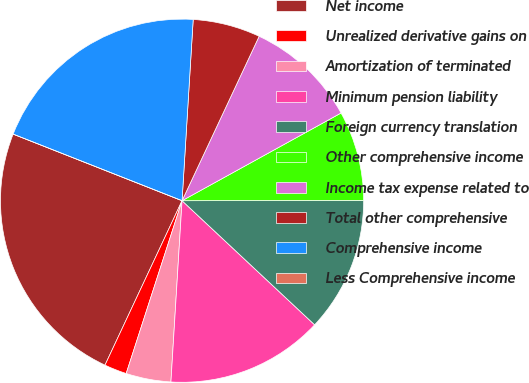<chart> <loc_0><loc_0><loc_500><loc_500><pie_chart><fcel>Net income<fcel>Unrealized derivative gains on<fcel>Amortization of terminated<fcel>Minimum pension liability<fcel>Foreign currency translation<fcel>Other comprehensive income<fcel>Income tax expense related to<fcel>Total other comprehensive<fcel>Comprehensive income<fcel>Less Comprehensive income<nl><fcel>24.0%<fcel>2.0%<fcel>4.0%<fcel>14.0%<fcel>12.0%<fcel>8.0%<fcel>10.0%<fcel>6.0%<fcel>20.0%<fcel>0.0%<nl></chart> 